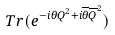Convert formula to latex. <formula><loc_0><loc_0><loc_500><loc_500>T r ( e ^ { - i \theta Q ^ { 2 } + i \overline { \theta } \overline { Q } ^ { 2 } } )</formula> 